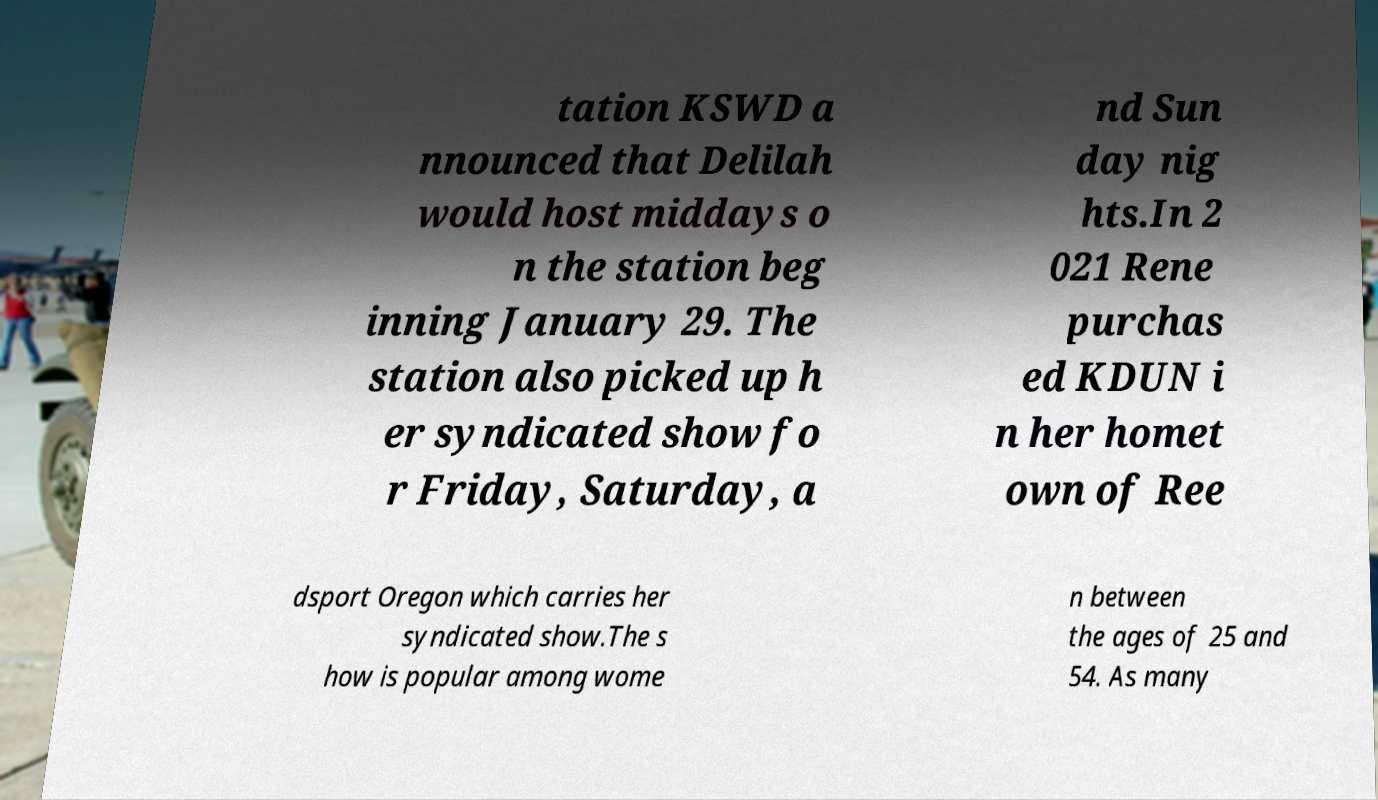Could you assist in decoding the text presented in this image and type it out clearly? tation KSWD a nnounced that Delilah would host middays o n the station beg inning January 29. The station also picked up h er syndicated show fo r Friday, Saturday, a nd Sun day nig hts.In 2 021 Rene purchas ed KDUN i n her homet own of Ree dsport Oregon which carries her syndicated show.The s how is popular among wome n between the ages of 25 and 54. As many 